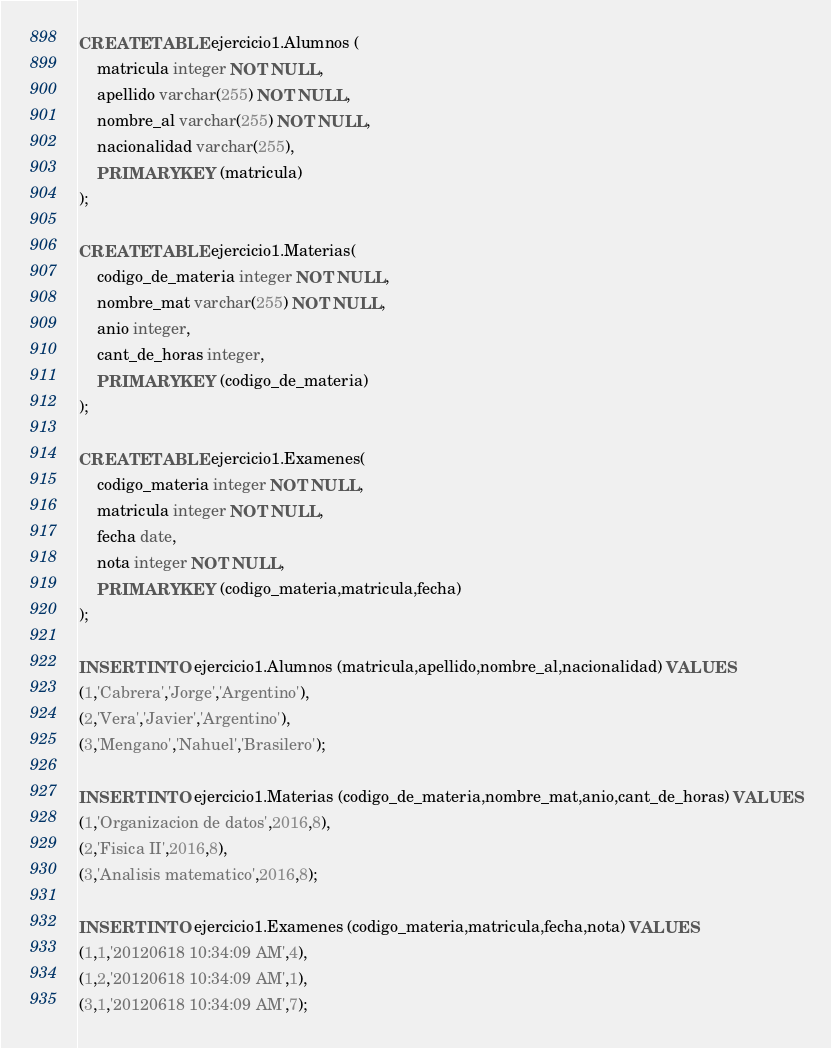Convert code to text. <code><loc_0><loc_0><loc_500><loc_500><_SQL_>CREATE TABLE ejercicio1.Alumnos (
    matricula integer NOT NULL,
    apellido varchar(255) NOT NULL,
    nombre_al varchar(255) NOT NULL,
    nacionalidad varchar(255),
	PRIMARY KEY (matricula)
);

CREATE TABLE ejercicio1.Materias(
	codigo_de_materia integer NOT NULL,
    nombre_mat varchar(255) NOT NULL,
    anio integer,
    cant_de_horas integer,
    PRIMARY KEY (codigo_de_materia)
);	

CREATE TABLE ejercicio1.Examenes(
	codigo_materia integer NOT NULL,
    matricula integer NOT NULL,
    fecha date,
    nota integer NOT NULL,
    PRIMARY KEY (codigo_materia,matricula,fecha)
);

INSERT INTO ejercicio1.Alumnos (matricula,apellido,nombre_al,nacionalidad) VALUES
(1,'Cabrera','Jorge','Argentino'),
(2,'Vera','Javier','Argentino'),
(3,'Mengano','Nahuel','Brasilero');

INSERT INTO ejercicio1.Materias (codigo_de_materia,nombre_mat,anio,cant_de_horas) VALUES
(1,'Organizacion de datos',2016,8),
(2,'Fisica II',2016,8),
(3,'Analisis matematico',2016,8);

INSERT INTO ejercicio1.Examenes (codigo_materia,matricula,fecha,nota) VALUES
(1,1,'20120618 10:34:09 AM',4),
(1,2,'20120618 10:34:09 AM',1),
(3,1,'20120618 10:34:09 AM',7);</code> 